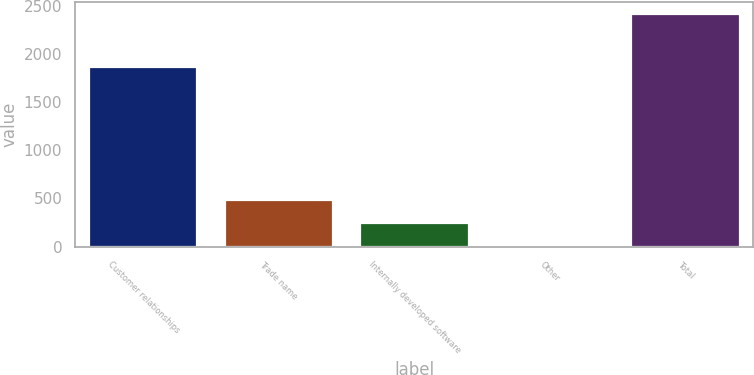<chart> <loc_0><loc_0><loc_500><loc_500><bar_chart><fcel>Customer relationships<fcel>Trade name<fcel>Internally developed software<fcel>Other<fcel>Total<nl><fcel>1860.8<fcel>485.16<fcel>244.13<fcel>3.1<fcel>2413.4<nl></chart> 